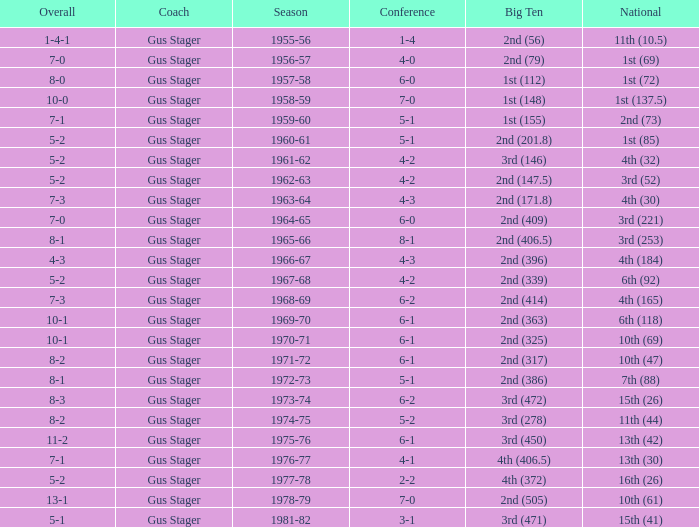What is the Coach with a Big Ten that is 3rd (278)? Gus Stager. 